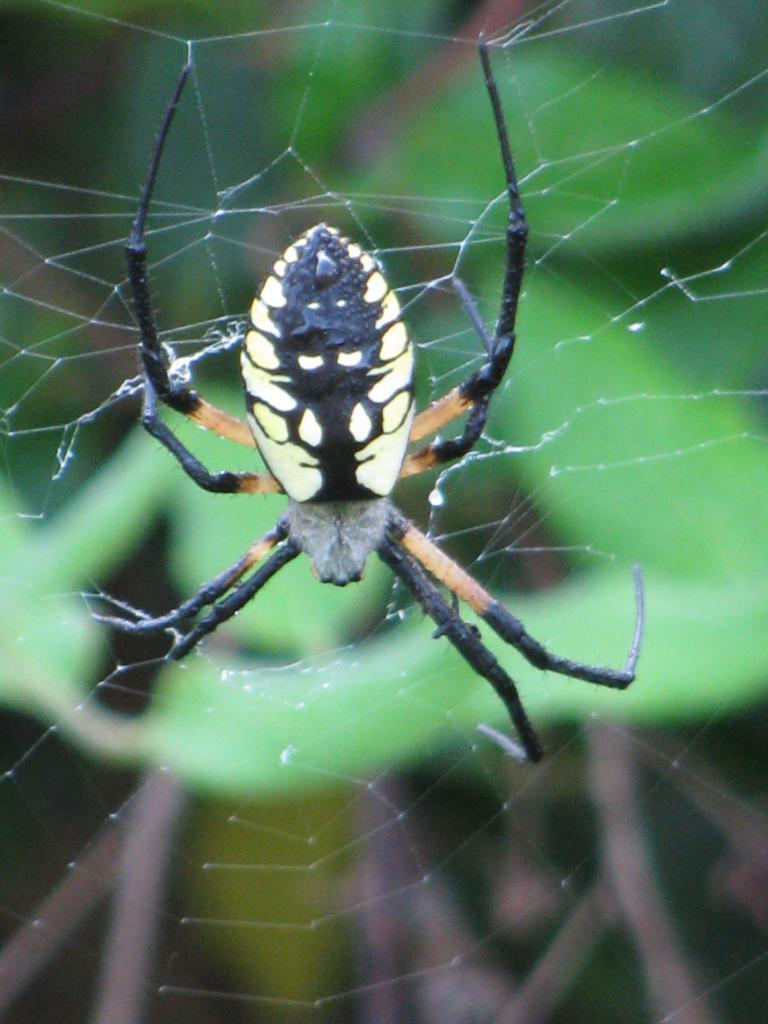What is present in the image? There is a spider in the image. Where is the spider located? The spider is in its web. How many trees can be seen in the image? There are no trees present in the image; it features a spider in its web. What type of bed is visible in the image? There is no bed present in the image. 